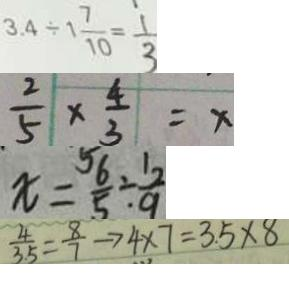<formula> <loc_0><loc_0><loc_500><loc_500>3 . 4 \div 1 \frac { 7 } { 1 0 } = \frac { 1 } { 3 } 
 \frac { 2 } { 5 } \times \frac { 4 } { 3 } = x 
 x = \frac { 5 6 } { 5 } \div \frac { 1 2 } { 9 } 
 \frac { 4 } { 3 . 5 } = \frac { 8 } { 7 } \rightarrow 4 \times 7 = 3 . 5 \times 8</formula> 